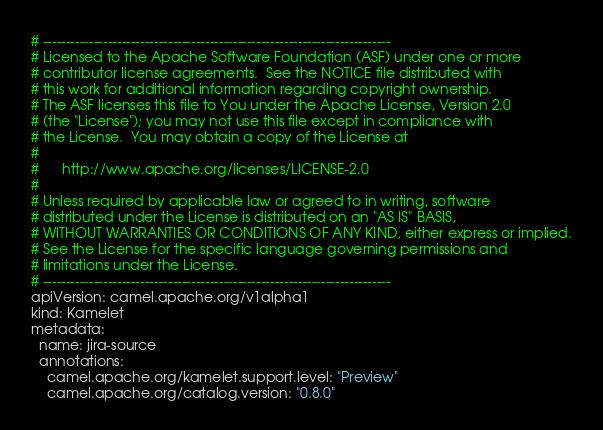Convert code to text. <code><loc_0><loc_0><loc_500><loc_500><_YAML_># ---------------------------------------------------------------------------
# Licensed to the Apache Software Foundation (ASF) under one or more
# contributor license agreements.  See the NOTICE file distributed with
# this work for additional information regarding copyright ownership.
# The ASF licenses this file to You under the Apache License, Version 2.0
# (the "License"); you may not use this file except in compliance with
# the License.  You may obtain a copy of the License at
#
#      http://www.apache.org/licenses/LICENSE-2.0
#
# Unless required by applicable law or agreed to in writing, software
# distributed under the License is distributed on an "AS IS" BASIS,
# WITHOUT WARRANTIES OR CONDITIONS OF ANY KIND, either express or implied.
# See the License for the specific language governing permissions and
# limitations under the License.
# ---------------------------------------------------------------------------
apiVersion: camel.apache.org/v1alpha1
kind: Kamelet
metadata:
  name: jira-source
  annotations:
    camel.apache.org/kamelet.support.level: "Preview"
    camel.apache.org/catalog.version: "0.8.0"</code> 